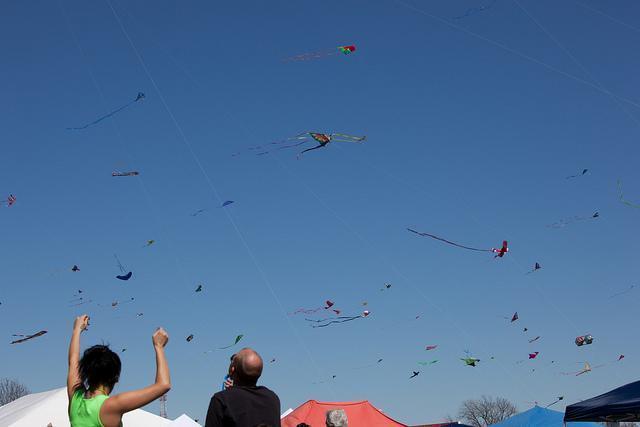How many people are in the picture?
Give a very brief answer. 3. How many people can be seen?
Give a very brief answer. 2. 